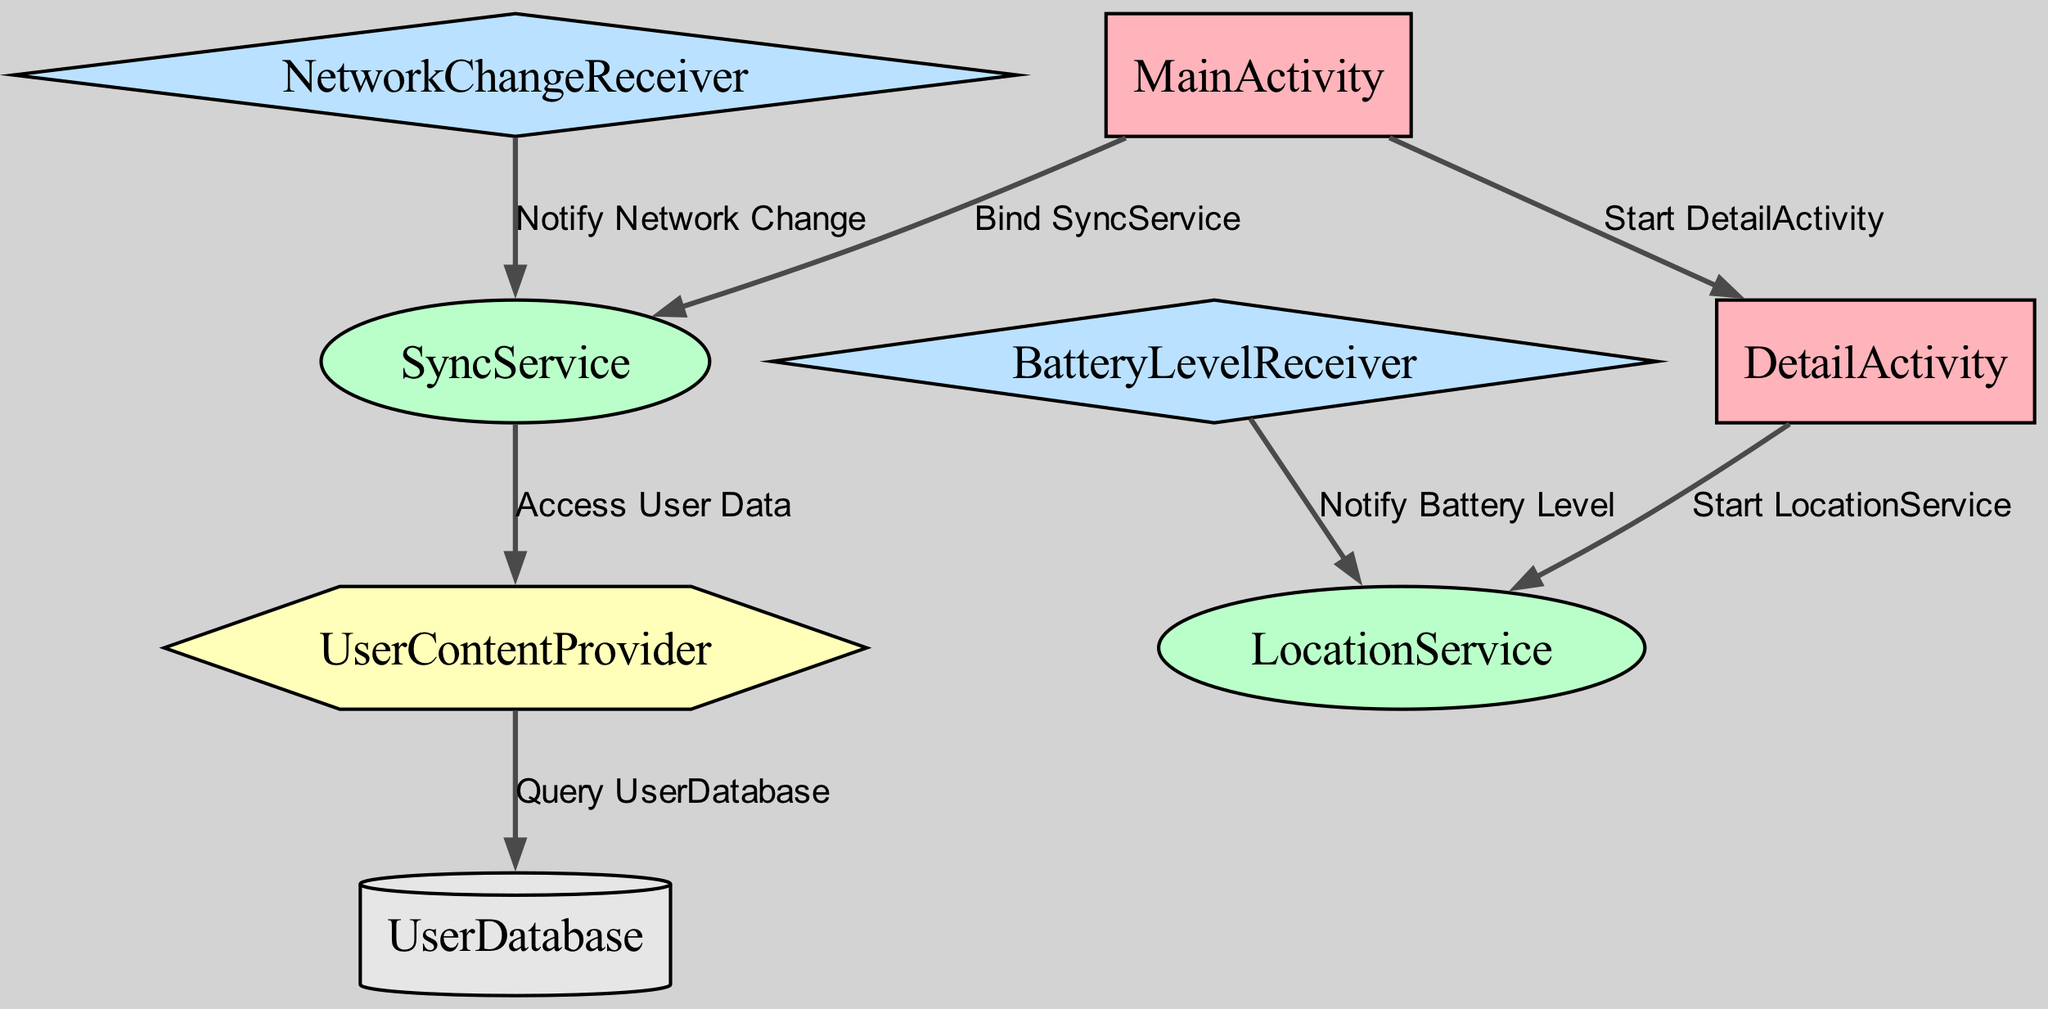What are the types of nodes present in the diagram? The diagram contains five types of nodes: Activities, Services, Broadcast Receivers, Content Providers, and a Database. By identifying each node's type, we can list them as they appear in the diagram.
Answer: Activities, Services, Broadcast Receivers, Content Providers, Database How many edges are there in the diagram? By counting the connections (edges) that link the nodes, we find a total of seven edges present in the diagram.
Answer: Seven What does "MainActivity" interact with to access user data? The "MainActivity" connects to the "SyncService" which then interacts with the "UserContentProvider" to access user data. Following the flow from MainActivity to SyncService and then to UserContentProvider leads us to the answer.
Answer: SyncService What type of service is "SyncService"? The diagram classifies "SyncService" as a Service, which is identified by its ellipse shape and color coding. By checking the node properties, this classification is confirmed.
Answer: Service How does "LocationService" get started? The "LocationService" is started from the "DetailActivity", as indicated by the directed edge connecting these two nodes. Analyzing the directional flow shows this relationship clearly.
Answer: DetailActivity Who notifies "SyncService" about network changes? The "NetworkChangeReceiver" notifies "SyncService" regarding network changes, as depicted by the directed edge pointing from the broadcast receiver node to the service node. This edge specifically indicates the notification flow.
Answer: NetworkChangeReceiver Which node queries the "UserDatabase"? The "UserContentProvider" queries the "UserDatabase", as shown by the directed edge from the content provider to the database. By following the flow directed towards the database node, we identify this relationship.
Answer: UserContentProvider What type of component is "BatteryLevelReceiver"? "BatteryLevelReceiver" is classified as a Broadcast Receiver, identifiable by its diamond shape and specific color in the diagram. By referencing the node type, we confirm its classification.
Answer: Broadcast Receiver Which activity is the entry point for the detailed view? The "MainActivity" serves as the entry point, as it is connected to the "DetailActivity" through the edge labeled "Start DetailActivity." Following the connection leads us to this conclusion.
Answer: MainActivity 